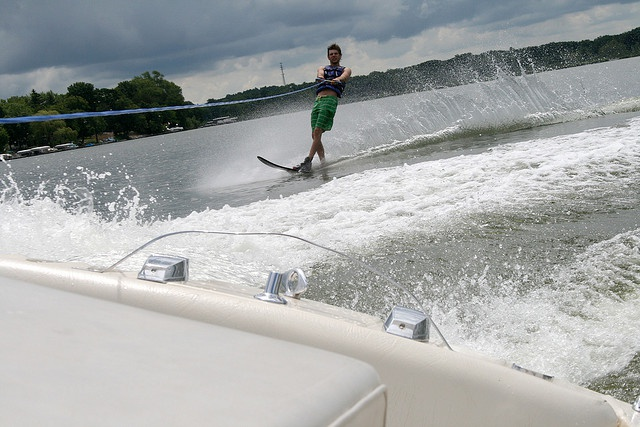Describe the objects in this image and their specific colors. I can see boat in gray, lightgray, and darkgray tones, people in gray, black, darkgreen, and darkgray tones, and surfboard in gray, darkgray, black, and lightgray tones in this image. 